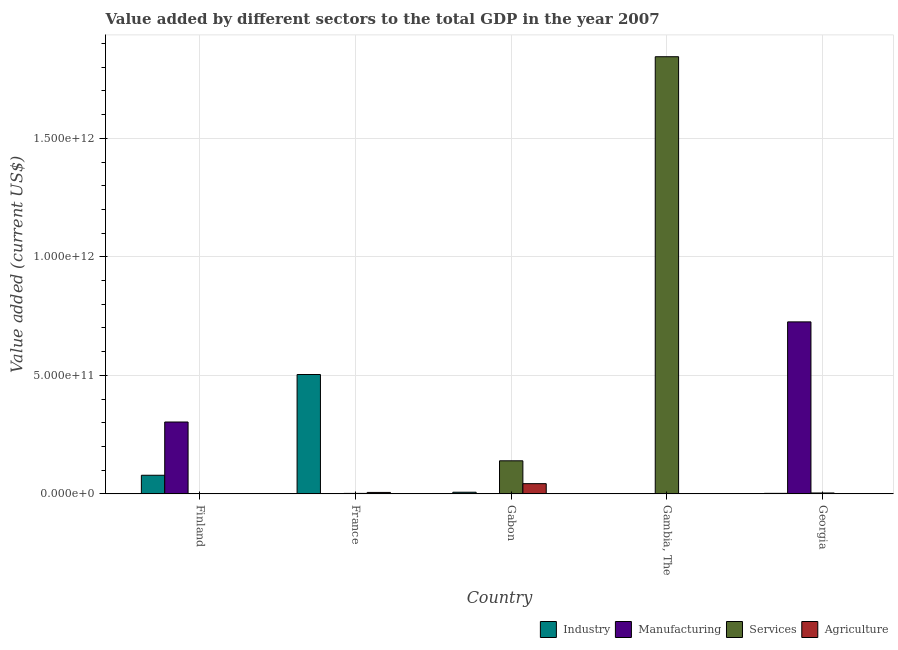How many different coloured bars are there?
Offer a terse response. 4. How many groups of bars are there?
Offer a terse response. 5. Are the number of bars per tick equal to the number of legend labels?
Ensure brevity in your answer.  Yes. How many bars are there on the 1st tick from the right?
Offer a terse response. 4. What is the label of the 3rd group of bars from the left?
Make the answer very short. Gabon. In how many cases, is the number of bars for a given country not equal to the number of legend labels?
Offer a terse response. 0. What is the value added by manufacturing sector in Georgia?
Ensure brevity in your answer.  7.26e+11. Across all countries, what is the maximum value added by services sector?
Offer a terse response. 1.84e+12. Across all countries, what is the minimum value added by manufacturing sector?
Provide a succinct answer. 5.33e+07. In which country was the value added by industrial sector maximum?
Offer a very short reply. France. In which country was the value added by agricultural sector minimum?
Give a very brief answer. Georgia. What is the total value added by agricultural sector in the graph?
Your response must be concise. 5.02e+1. What is the difference between the value added by services sector in Finland and that in Georgia?
Your answer should be very brief. -2.49e+09. What is the difference between the value added by industrial sector in Finland and the value added by manufacturing sector in France?
Keep it short and to the point. 7.82e+1. What is the average value added by industrial sector per country?
Offer a terse response. 1.18e+11. What is the difference between the value added by agricultural sector and value added by industrial sector in Finland?
Your response must be concise. -7.81e+1. What is the ratio of the value added by agricultural sector in Finland to that in Georgia?
Give a very brief answer. 2.46. Is the value added by services sector in France less than that in Gambia, The?
Offer a terse response. Yes. Is the difference between the value added by manufacturing sector in Finland and Georgia greater than the difference between the value added by agricultural sector in Finland and Georgia?
Your answer should be very brief. No. What is the difference between the highest and the second highest value added by manufacturing sector?
Ensure brevity in your answer.  4.22e+11. What is the difference between the highest and the lowest value added by manufacturing sector?
Your answer should be very brief. 7.26e+11. Is the sum of the value added by industrial sector in Finland and Gabon greater than the maximum value added by manufacturing sector across all countries?
Your answer should be very brief. No. Is it the case that in every country, the sum of the value added by industrial sector and value added by services sector is greater than the sum of value added by agricultural sector and value added by manufacturing sector?
Provide a short and direct response. Yes. What does the 2nd bar from the left in France represents?
Give a very brief answer. Manufacturing. What does the 4th bar from the right in Gabon represents?
Offer a very short reply. Industry. Is it the case that in every country, the sum of the value added by industrial sector and value added by manufacturing sector is greater than the value added by services sector?
Give a very brief answer. No. Are all the bars in the graph horizontal?
Your answer should be compact. No. How many countries are there in the graph?
Provide a succinct answer. 5. What is the difference between two consecutive major ticks on the Y-axis?
Offer a very short reply. 5.00e+11. Does the graph contain grids?
Offer a terse response. Yes. What is the title of the graph?
Offer a terse response. Value added by different sectors to the total GDP in the year 2007. Does "United States" appear as one of the legend labels in the graph?
Your response must be concise. No. What is the label or title of the X-axis?
Your answer should be very brief. Country. What is the label or title of the Y-axis?
Give a very brief answer. Value added (current US$). What is the Value added (current US$) of Industry in Finland?
Your answer should be compact. 7.85e+1. What is the Value added (current US$) in Manufacturing in Finland?
Give a very brief answer. 3.03e+11. What is the Value added (current US$) in Services in Finland?
Offer a very short reply. 1.25e+09. What is the Value added (current US$) of Agriculture in Finland?
Give a very brief answer. 4.01e+08. What is the Value added (current US$) of Industry in France?
Your answer should be compact. 5.04e+11. What is the Value added (current US$) in Manufacturing in France?
Provide a succinct answer. 3.14e+08. What is the Value added (current US$) in Services in France?
Provide a short and direct response. 1.96e+09. What is the Value added (current US$) in Agriculture in France?
Offer a very short reply. 6.01e+09. What is the Value added (current US$) of Industry in Gabon?
Give a very brief answer. 6.93e+09. What is the Value added (current US$) in Manufacturing in Gabon?
Your answer should be very brief. 5.33e+07. What is the Value added (current US$) in Services in Gabon?
Provide a succinct answer. 1.39e+11. What is the Value added (current US$) of Agriculture in Gabon?
Your response must be concise. 4.30e+1. What is the Value added (current US$) in Industry in Gambia, The?
Your response must be concise. 1.09e+08. What is the Value added (current US$) of Manufacturing in Gambia, The?
Provide a short and direct response. 1.11e+09. What is the Value added (current US$) in Services in Gambia, The?
Give a very brief answer. 1.84e+12. What is the Value added (current US$) in Agriculture in Gambia, The?
Your answer should be very brief. 6.17e+08. What is the Value added (current US$) in Industry in Georgia?
Offer a very short reply. 2.13e+09. What is the Value added (current US$) of Manufacturing in Georgia?
Ensure brevity in your answer.  7.26e+11. What is the Value added (current US$) of Services in Georgia?
Offer a terse response. 3.74e+09. What is the Value added (current US$) of Agriculture in Georgia?
Your answer should be very brief. 1.63e+08. Across all countries, what is the maximum Value added (current US$) in Industry?
Your response must be concise. 5.04e+11. Across all countries, what is the maximum Value added (current US$) of Manufacturing?
Offer a terse response. 7.26e+11. Across all countries, what is the maximum Value added (current US$) of Services?
Keep it short and to the point. 1.84e+12. Across all countries, what is the maximum Value added (current US$) in Agriculture?
Offer a very short reply. 4.30e+1. Across all countries, what is the minimum Value added (current US$) in Industry?
Give a very brief answer. 1.09e+08. Across all countries, what is the minimum Value added (current US$) of Manufacturing?
Provide a succinct answer. 5.33e+07. Across all countries, what is the minimum Value added (current US$) of Services?
Your answer should be very brief. 1.25e+09. Across all countries, what is the minimum Value added (current US$) of Agriculture?
Provide a succinct answer. 1.63e+08. What is the total Value added (current US$) in Industry in the graph?
Offer a very short reply. 5.91e+11. What is the total Value added (current US$) of Manufacturing in the graph?
Provide a succinct answer. 1.03e+12. What is the total Value added (current US$) in Services in the graph?
Your response must be concise. 1.99e+12. What is the total Value added (current US$) in Agriculture in the graph?
Your answer should be very brief. 5.02e+1. What is the difference between the Value added (current US$) of Industry in Finland and that in France?
Offer a terse response. -4.25e+11. What is the difference between the Value added (current US$) of Manufacturing in Finland and that in France?
Make the answer very short. 3.03e+11. What is the difference between the Value added (current US$) of Services in Finland and that in France?
Your answer should be very brief. -7.13e+08. What is the difference between the Value added (current US$) in Agriculture in Finland and that in France?
Keep it short and to the point. -5.61e+09. What is the difference between the Value added (current US$) of Industry in Finland and that in Gabon?
Your response must be concise. 7.16e+1. What is the difference between the Value added (current US$) in Manufacturing in Finland and that in Gabon?
Ensure brevity in your answer.  3.03e+11. What is the difference between the Value added (current US$) in Services in Finland and that in Gabon?
Provide a succinct answer. -1.38e+11. What is the difference between the Value added (current US$) of Agriculture in Finland and that in Gabon?
Offer a terse response. -4.26e+1. What is the difference between the Value added (current US$) of Industry in Finland and that in Gambia, The?
Keep it short and to the point. 7.84e+1. What is the difference between the Value added (current US$) in Manufacturing in Finland and that in Gambia, The?
Provide a short and direct response. 3.02e+11. What is the difference between the Value added (current US$) in Services in Finland and that in Gambia, The?
Ensure brevity in your answer.  -1.84e+12. What is the difference between the Value added (current US$) of Agriculture in Finland and that in Gambia, The?
Your response must be concise. -2.15e+08. What is the difference between the Value added (current US$) in Industry in Finland and that in Georgia?
Ensure brevity in your answer.  7.64e+1. What is the difference between the Value added (current US$) in Manufacturing in Finland and that in Georgia?
Offer a very short reply. -4.22e+11. What is the difference between the Value added (current US$) of Services in Finland and that in Georgia?
Offer a very short reply. -2.49e+09. What is the difference between the Value added (current US$) of Agriculture in Finland and that in Georgia?
Offer a terse response. 2.38e+08. What is the difference between the Value added (current US$) of Industry in France and that in Gabon?
Keep it short and to the point. 4.97e+11. What is the difference between the Value added (current US$) of Manufacturing in France and that in Gabon?
Offer a very short reply. 2.61e+08. What is the difference between the Value added (current US$) of Services in France and that in Gabon?
Offer a very short reply. -1.38e+11. What is the difference between the Value added (current US$) in Agriculture in France and that in Gabon?
Your answer should be very brief. -3.70e+1. What is the difference between the Value added (current US$) of Industry in France and that in Gambia, The?
Make the answer very short. 5.03e+11. What is the difference between the Value added (current US$) in Manufacturing in France and that in Gambia, The?
Your response must be concise. -8.00e+08. What is the difference between the Value added (current US$) of Services in France and that in Gambia, The?
Keep it short and to the point. -1.84e+12. What is the difference between the Value added (current US$) of Agriculture in France and that in Gambia, The?
Give a very brief answer. 5.39e+09. What is the difference between the Value added (current US$) of Industry in France and that in Georgia?
Ensure brevity in your answer.  5.01e+11. What is the difference between the Value added (current US$) in Manufacturing in France and that in Georgia?
Keep it short and to the point. -7.25e+11. What is the difference between the Value added (current US$) in Services in France and that in Georgia?
Your response must be concise. -1.78e+09. What is the difference between the Value added (current US$) in Agriculture in France and that in Georgia?
Your response must be concise. 5.85e+09. What is the difference between the Value added (current US$) of Industry in Gabon and that in Gambia, The?
Give a very brief answer. 6.82e+09. What is the difference between the Value added (current US$) in Manufacturing in Gabon and that in Gambia, The?
Ensure brevity in your answer.  -1.06e+09. What is the difference between the Value added (current US$) of Services in Gabon and that in Gambia, The?
Your response must be concise. -1.70e+12. What is the difference between the Value added (current US$) in Agriculture in Gabon and that in Gambia, The?
Make the answer very short. 4.24e+1. What is the difference between the Value added (current US$) of Industry in Gabon and that in Georgia?
Keep it short and to the point. 4.81e+09. What is the difference between the Value added (current US$) in Manufacturing in Gabon and that in Georgia?
Offer a very short reply. -7.26e+11. What is the difference between the Value added (current US$) of Services in Gabon and that in Georgia?
Make the answer very short. 1.36e+11. What is the difference between the Value added (current US$) in Agriculture in Gabon and that in Georgia?
Give a very brief answer. 4.29e+1. What is the difference between the Value added (current US$) of Industry in Gambia, The and that in Georgia?
Keep it short and to the point. -2.02e+09. What is the difference between the Value added (current US$) in Manufacturing in Gambia, The and that in Georgia?
Offer a very short reply. -7.24e+11. What is the difference between the Value added (current US$) of Services in Gambia, The and that in Georgia?
Your response must be concise. 1.84e+12. What is the difference between the Value added (current US$) of Agriculture in Gambia, The and that in Georgia?
Your answer should be compact. 4.53e+08. What is the difference between the Value added (current US$) in Industry in Finland and the Value added (current US$) in Manufacturing in France?
Ensure brevity in your answer.  7.82e+1. What is the difference between the Value added (current US$) in Industry in Finland and the Value added (current US$) in Services in France?
Make the answer very short. 7.66e+1. What is the difference between the Value added (current US$) of Industry in Finland and the Value added (current US$) of Agriculture in France?
Provide a succinct answer. 7.25e+1. What is the difference between the Value added (current US$) of Manufacturing in Finland and the Value added (current US$) of Services in France?
Your response must be concise. 3.01e+11. What is the difference between the Value added (current US$) of Manufacturing in Finland and the Value added (current US$) of Agriculture in France?
Provide a short and direct response. 2.97e+11. What is the difference between the Value added (current US$) of Services in Finland and the Value added (current US$) of Agriculture in France?
Make the answer very short. -4.76e+09. What is the difference between the Value added (current US$) in Industry in Finland and the Value added (current US$) in Manufacturing in Gabon?
Make the answer very short. 7.85e+1. What is the difference between the Value added (current US$) of Industry in Finland and the Value added (current US$) of Services in Gabon?
Offer a terse response. -6.10e+1. What is the difference between the Value added (current US$) in Industry in Finland and the Value added (current US$) in Agriculture in Gabon?
Give a very brief answer. 3.55e+1. What is the difference between the Value added (current US$) in Manufacturing in Finland and the Value added (current US$) in Services in Gabon?
Provide a succinct answer. 1.64e+11. What is the difference between the Value added (current US$) of Manufacturing in Finland and the Value added (current US$) of Agriculture in Gabon?
Ensure brevity in your answer.  2.60e+11. What is the difference between the Value added (current US$) of Services in Finland and the Value added (current US$) of Agriculture in Gabon?
Your response must be concise. -4.18e+1. What is the difference between the Value added (current US$) of Industry in Finland and the Value added (current US$) of Manufacturing in Gambia, The?
Make the answer very short. 7.74e+1. What is the difference between the Value added (current US$) of Industry in Finland and the Value added (current US$) of Services in Gambia, The?
Make the answer very short. -1.77e+12. What is the difference between the Value added (current US$) of Industry in Finland and the Value added (current US$) of Agriculture in Gambia, The?
Your answer should be very brief. 7.79e+1. What is the difference between the Value added (current US$) in Manufacturing in Finland and the Value added (current US$) in Services in Gambia, The?
Provide a short and direct response. -1.54e+12. What is the difference between the Value added (current US$) of Manufacturing in Finland and the Value added (current US$) of Agriculture in Gambia, The?
Provide a short and direct response. 3.03e+11. What is the difference between the Value added (current US$) of Services in Finland and the Value added (current US$) of Agriculture in Gambia, The?
Ensure brevity in your answer.  6.33e+08. What is the difference between the Value added (current US$) of Industry in Finland and the Value added (current US$) of Manufacturing in Georgia?
Ensure brevity in your answer.  -6.47e+11. What is the difference between the Value added (current US$) in Industry in Finland and the Value added (current US$) in Services in Georgia?
Keep it short and to the point. 7.48e+1. What is the difference between the Value added (current US$) of Industry in Finland and the Value added (current US$) of Agriculture in Georgia?
Your response must be concise. 7.84e+1. What is the difference between the Value added (current US$) of Manufacturing in Finland and the Value added (current US$) of Services in Georgia?
Your response must be concise. 2.99e+11. What is the difference between the Value added (current US$) in Manufacturing in Finland and the Value added (current US$) in Agriculture in Georgia?
Make the answer very short. 3.03e+11. What is the difference between the Value added (current US$) in Services in Finland and the Value added (current US$) in Agriculture in Georgia?
Make the answer very short. 1.09e+09. What is the difference between the Value added (current US$) of Industry in France and the Value added (current US$) of Manufacturing in Gabon?
Provide a succinct answer. 5.04e+11. What is the difference between the Value added (current US$) in Industry in France and the Value added (current US$) in Services in Gabon?
Provide a short and direct response. 3.64e+11. What is the difference between the Value added (current US$) of Industry in France and the Value added (current US$) of Agriculture in Gabon?
Your answer should be very brief. 4.61e+11. What is the difference between the Value added (current US$) of Manufacturing in France and the Value added (current US$) of Services in Gabon?
Offer a very short reply. -1.39e+11. What is the difference between the Value added (current US$) in Manufacturing in France and the Value added (current US$) in Agriculture in Gabon?
Offer a terse response. -4.27e+1. What is the difference between the Value added (current US$) of Services in France and the Value added (current US$) of Agriculture in Gabon?
Give a very brief answer. -4.11e+1. What is the difference between the Value added (current US$) in Industry in France and the Value added (current US$) in Manufacturing in Gambia, The?
Your response must be concise. 5.02e+11. What is the difference between the Value added (current US$) of Industry in France and the Value added (current US$) of Services in Gambia, The?
Give a very brief answer. -1.34e+12. What is the difference between the Value added (current US$) of Industry in France and the Value added (current US$) of Agriculture in Gambia, The?
Keep it short and to the point. 5.03e+11. What is the difference between the Value added (current US$) of Manufacturing in France and the Value added (current US$) of Services in Gambia, The?
Your response must be concise. -1.84e+12. What is the difference between the Value added (current US$) of Manufacturing in France and the Value added (current US$) of Agriculture in Gambia, The?
Make the answer very short. -3.03e+08. What is the difference between the Value added (current US$) of Services in France and the Value added (current US$) of Agriculture in Gambia, The?
Make the answer very short. 1.35e+09. What is the difference between the Value added (current US$) in Industry in France and the Value added (current US$) in Manufacturing in Georgia?
Make the answer very short. -2.22e+11. What is the difference between the Value added (current US$) of Industry in France and the Value added (current US$) of Services in Georgia?
Your answer should be very brief. 5.00e+11. What is the difference between the Value added (current US$) in Industry in France and the Value added (current US$) in Agriculture in Georgia?
Offer a terse response. 5.03e+11. What is the difference between the Value added (current US$) of Manufacturing in France and the Value added (current US$) of Services in Georgia?
Provide a succinct answer. -3.43e+09. What is the difference between the Value added (current US$) in Manufacturing in France and the Value added (current US$) in Agriculture in Georgia?
Ensure brevity in your answer.  1.51e+08. What is the difference between the Value added (current US$) in Services in France and the Value added (current US$) in Agriculture in Georgia?
Provide a succinct answer. 1.80e+09. What is the difference between the Value added (current US$) in Industry in Gabon and the Value added (current US$) in Manufacturing in Gambia, The?
Provide a succinct answer. 5.82e+09. What is the difference between the Value added (current US$) of Industry in Gabon and the Value added (current US$) of Services in Gambia, The?
Offer a very short reply. -1.84e+12. What is the difference between the Value added (current US$) in Industry in Gabon and the Value added (current US$) in Agriculture in Gambia, The?
Provide a short and direct response. 6.32e+09. What is the difference between the Value added (current US$) in Manufacturing in Gabon and the Value added (current US$) in Services in Gambia, The?
Provide a succinct answer. -1.84e+12. What is the difference between the Value added (current US$) in Manufacturing in Gabon and the Value added (current US$) in Agriculture in Gambia, The?
Keep it short and to the point. -5.63e+08. What is the difference between the Value added (current US$) in Services in Gabon and the Value added (current US$) in Agriculture in Gambia, The?
Your response must be concise. 1.39e+11. What is the difference between the Value added (current US$) in Industry in Gabon and the Value added (current US$) in Manufacturing in Georgia?
Provide a succinct answer. -7.19e+11. What is the difference between the Value added (current US$) of Industry in Gabon and the Value added (current US$) of Services in Georgia?
Your answer should be compact. 3.19e+09. What is the difference between the Value added (current US$) in Industry in Gabon and the Value added (current US$) in Agriculture in Georgia?
Provide a succinct answer. 6.77e+09. What is the difference between the Value added (current US$) in Manufacturing in Gabon and the Value added (current US$) in Services in Georgia?
Offer a terse response. -3.69e+09. What is the difference between the Value added (current US$) in Manufacturing in Gabon and the Value added (current US$) in Agriculture in Georgia?
Your answer should be compact. -1.10e+08. What is the difference between the Value added (current US$) of Services in Gabon and the Value added (current US$) of Agriculture in Georgia?
Your answer should be compact. 1.39e+11. What is the difference between the Value added (current US$) of Industry in Gambia, The and the Value added (current US$) of Manufacturing in Georgia?
Your answer should be compact. -7.25e+11. What is the difference between the Value added (current US$) of Industry in Gambia, The and the Value added (current US$) of Services in Georgia?
Provide a succinct answer. -3.63e+09. What is the difference between the Value added (current US$) in Industry in Gambia, The and the Value added (current US$) in Agriculture in Georgia?
Provide a short and direct response. -5.41e+07. What is the difference between the Value added (current US$) of Manufacturing in Gambia, The and the Value added (current US$) of Services in Georgia?
Keep it short and to the point. -2.63e+09. What is the difference between the Value added (current US$) of Manufacturing in Gambia, The and the Value added (current US$) of Agriculture in Georgia?
Provide a succinct answer. 9.50e+08. What is the difference between the Value added (current US$) of Services in Gambia, The and the Value added (current US$) of Agriculture in Georgia?
Your response must be concise. 1.84e+12. What is the average Value added (current US$) in Industry per country?
Give a very brief answer. 1.18e+11. What is the average Value added (current US$) in Manufacturing per country?
Provide a succinct answer. 2.06e+11. What is the average Value added (current US$) of Services per country?
Keep it short and to the point. 3.98e+11. What is the average Value added (current US$) in Agriculture per country?
Keep it short and to the point. 1.00e+1. What is the difference between the Value added (current US$) in Industry and Value added (current US$) in Manufacturing in Finland?
Make the answer very short. -2.25e+11. What is the difference between the Value added (current US$) of Industry and Value added (current US$) of Services in Finland?
Provide a short and direct response. 7.73e+1. What is the difference between the Value added (current US$) in Industry and Value added (current US$) in Agriculture in Finland?
Offer a very short reply. 7.81e+1. What is the difference between the Value added (current US$) in Manufacturing and Value added (current US$) in Services in Finland?
Your answer should be compact. 3.02e+11. What is the difference between the Value added (current US$) of Manufacturing and Value added (current US$) of Agriculture in Finland?
Keep it short and to the point. 3.03e+11. What is the difference between the Value added (current US$) in Services and Value added (current US$) in Agriculture in Finland?
Keep it short and to the point. 8.48e+08. What is the difference between the Value added (current US$) in Industry and Value added (current US$) in Manufacturing in France?
Make the answer very short. 5.03e+11. What is the difference between the Value added (current US$) in Industry and Value added (current US$) in Services in France?
Your response must be concise. 5.02e+11. What is the difference between the Value added (current US$) in Industry and Value added (current US$) in Agriculture in France?
Keep it short and to the point. 4.98e+11. What is the difference between the Value added (current US$) of Manufacturing and Value added (current US$) of Services in France?
Offer a terse response. -1.65e+09. What is the difference between the Value added (current US$) of Manufacturing and Value added (current US$) of Agriculture in France?
Offer a very short reply. -5.70e+09. What is the difference between the Value added (current US$) of Services and Value added (current US$) of Agriculture in France?
Offer a terse response. -4.05e+09. What is the difference between the Value added (current US$) of Industry and Value added (current US$) of Manufacturing in Gabon?
Provide a short and direct response. 6.88e+09. What is the difference between the Value added (current US$) of Industry and Value added (current US$) of Services in Gabon?
Give a very brief answer. -1.33e+11. What is the difference between the Value added (current US$) of Industry and Value added (current US$) of Agriculture in Gabon?
Make the answer very short. -3.61e+1. What is the difference between the Value added (current US$) in Manufacturing and Value added (current US$) in Services in Gabon?
Your response must be concise. -1.39e+11. What is the difference between the Value added (current US$) in Manufacturing and Value added (current US$) in Agriculture in Gabon?
Your response must be concise. -4.30e+1. What is the difference between the Value added (current US$) in Services and Value added (current US$) in Agriculture in Gabon?
Keep it short and to the point. 9.64e+1. What is the difference between the Value added (current US$) in Industry and Value added (current US$) in Manufacturing in Gambia, The?
Give a very brief answer. -1.00e+09. What is the difference between the Value added (current US$) of Industry and Value added (current US$) of Services in Gambia, The?
Provide a short and direct response. -1.84e+12. What is the difference between the Value added (current US$) in Industry and Value added (current US$) in Agriculture in Gambia, The?
Give a very brief answer. -5.07e+08. What is the difference between the Value added (current US$) of Manufacturing and Value added (current US$) of Services in Gambia, The?
Your answer should be very brief. -1.84e+12. What is the difference between the Value added (current US$) in Manufacturing and Value added (current US$) in Agriculture in Gambia, The?
Provide a succinct answer. 4.97e+08. What is the difference between the Value added (current US$) in Services and Value added (current US$) in Agriculture in Gambia, The?
Your answer should be very brief. 1.84e+12. What is the difference between the Value added (current US$) in Industry and Value added (current US$) in Manufacturing in Georgia?
Give a very brief answer. -7.23e+11. What is the difference between the Value added (current US$) in Industry and Value added (current US$) in Services in Georgia?
Offer a terse response. -1.61e+09. What is the difference between the Value added (current US$) in Industry and Value added (current US$) in Agriculture in Georgia?
Give a very brief answer. 1.96e+09. What is the difference between the Value added (current US$) in Manufacturing and Value added (current US$) in Services in Georgia?
Provide a short and direct response. 7.22e+11. What is the difference between the Value added (current US$) in Manufacturing and Value added (current US$) in Agriculture in Georgia?
Offer a very short reply. 7.25e+11. What is the difference between the Value added (current US$) in Services and Value added (current US$) in Agriculture in Georgia?
Provide a short and direct response. 3.58e+09. What is the ratio of the Value added (current US$) in Industry in Finland to that in France?
Provide a succinct answer. 0.16. What is the ratio of the Value added (current US$) in Manufacturing in Finland to that in France?
Your answer should be very brief. 965.11. What is the ratio of the Value added (current US$) in Services in Finland to that in France?
Offer a terse response. 0.64. What is the ratio of the Value added (current US$) in Agriculture in Finland to that in France?
Your response must be concise. 0.07. What is the ratio of the Value added (current US$) of Industry in Finland to that in Gabon?
Provide a succinct answer. 11.33. What is the ratio of the Value added (current US$) of Manufacturing in Finland to that in Gabon?
Provide a short and direct response. 5683.42. What is the ratio of the Value added (current US$) in Services in Finland to that in Gabon?
Provide a short and direct response. 0.01. What is the ratio of the Value added (current US$) of Agriculture in Finland to that in Gabon?
Offer a very short reply. 0.01. What is the ratio of the Value added (current US$) of Industry in Finland to that in Gambia, The?
Offer a terse response. 717.94. What is the ratio of the Value added (current US$) in Manufacturing in Finland to that in Gambia, The?
Make the answer very short. 272.2. What is the ratio of the Value added (current US$) of Services in Finland to that in Gambia, The?
Your answer should be very brief. 0. What is the ratio of the Value added (current US$) in Agriculture in Finland to that in Gambia, The?
Your response must be concise. 0.65. What is the ratio of the Value added (current US$) of Industry in Finland to that in Georgia?
Provide a short and direct response. 36.93. What is the ratio of the Value added (current US$) of Manufacturing in Finland to that in Georgia?
Provide a short and direct response. 0.42. What is the ratio of the Value added (current US$) in Services in Finland to that in Georgia?
Provide a short and direct response. 0.33. What is the ratio of the Value added (current US$) in Agriculture in Finland to that in Georgia?
Keep it short and to the point. 2.46. What is the ratio of the Value added (current US$) of Industry in France to that in Gabon?
Your response must be concise. 72.65. What is the ratio of the Value added (current US$) of Manufacturing in France to that in Gabon?
Keep it short and to the point. 5.89. What is the ratio of the Value added (current US$) in Services in France to that in Gabon?
Your answer should be very brief. 0.01. What is the ratio of the Value added (current US$) of Agriculture in France to that in Gabon?
Make the answer very short. 0.14. What is the ratio of the Value added (current US$) in Industry in France to that in Gambia, The?
Offer a very short reply. 4604.68. What is the ratio of the Value added (current US$) in Manufacturing in France to that in Gambia, The?
Your response must be concise. 0.28. What is the ratio of the Value added (current US$) in Services in France to that in Gambia, The?
Your answer should be very brief. 0. What is the ratio of the Value added (current US$) in Agriculture in France to that in Gambia, The?
Give a very brief answer. 9.75. What is the ratio of the Value added (current US$) in Industry in France to that in Georgia?
Provide a short and direct response. 236.86. What is the ratio of the Value added (current US$) in Manufacturing in France to that in Georgia?
Offer a very short reply. 0. What is the ratio of the Value added (current US$) in Services in France to that in Georgia?
Your answer should be very brief. 0.52. What is the ratio of the Value added (current US$) of Agriculture in France to that in Georgia?
Offer a terse response. 36.77. What is the ratio of the Value added (current US$) of Industry in Gabon to that in Gambia, The?
Give a very brief answer. 63.38. What is the ratio of the Value added (current US$) of Manufacturing in Gabon to that in Gambia, The?
Your answer should be very brief. 0.05. What is the ratio of the Value added (current US$) of Services in Gabon to that in Gambia, The?
Make the answer very short. 0.08. What is the ratio of the Value added (current US$) of Agriculture in Gabon to that in Gambia, The?
Make the answer very short. 69.8. What is the ratio of the Value added (current US$) in Industry in Gabon to that in Georgia?
Give a very brief answer. 3.26. What is the ratio of the Value added (current US$) of Manufacturing in Gabon to that in Georgia?
Make the answer very short. 0. What is the ratio of the Value added (current US$) of Services in Gabon to that in Georgia?
Ensure brevity in your answer.  37.28. What is the ratio of the Value added (current US$) in Agriculture in Gabon to that in Georgia?
Your answer should be compact. 263.33. What is the ratio of the Value added (current US$) of Industry in Gambia, The to that in Georgia?
Provide a succinct answer. 0.05. What is the ratio of the Value added (current US$) of Manufacturing in Gambia, The to that in Georgia?
Offer a terse response. 0. What is the ratio of the Value added (current US$) of Services in Gambia, The to that in Georgia?
Offer a terse response. 492.98. What is the ratio of the Value added (current US$) of Agriculture in Gambia, The to that in Georgia?
Keep it short and to the point. 3.77. What is the difference between the highest and the second highest Value added (current US$) of Industry?
Keep it short and to the point. 4.25e+11. What is the difference between the highest and the second highest Value added (current US$) in Manufacturing?
Give a very brief answer. 4.22e+11. What is the difference between the highest and the second highest Value added (current US$) of Services?
Offer a terse response. 1.70e+12. What is the difference between the highest and the second highest Value added (current US$) of Agriculture?
Offer a terse response. 3.70e+1. What is the difference between the highest and the lowest Value added (current US$) of Industry?
Keep it short and to the point. 5.03e+11. What is the difference between the highest and the lowest Value added (current US$) of Manufacturing?
Give a very brief answer. 7.26e+11. What is the difference between the highest and the lowest Value added (current US$) in Services?
Provide a succinct answer. 1.84e+12. What is the difference between the highest and the lowest Value added (current US$) in Agriculture?
Make the answer very short. 4.29e+1. 